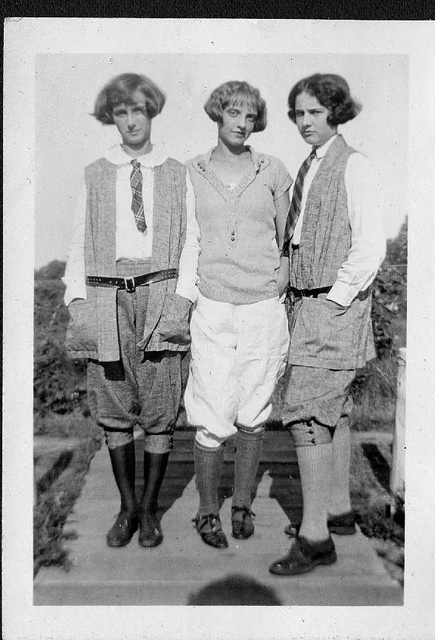<image>Where is the cap? It is ambiguous where the cap is. It could be anywhere including in hand, on the ground, in pocket or elsewhere. Where is the cap? I don't know where the cap is. It is not visible in the image. 